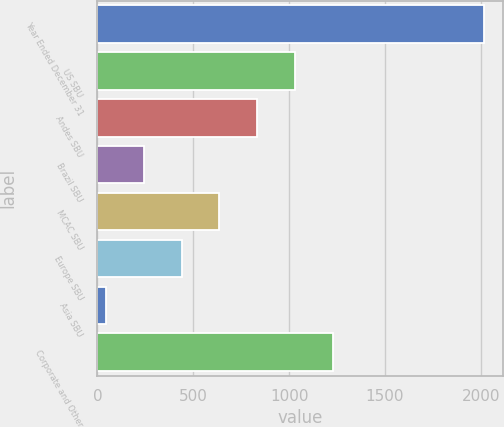Convert chart to OTSL. <chart><loc_0><loc_0><loc_500><loc_500><bar_chart><fcel>Year Ended December 31<fcel>US SBU<fcel>Andes SBU<fcel>Brazil SBU<fcel>MCAC SBU<fcel>Europe SBU<fcel>Asia SBU<fcel>Corporate and Other<nl><fcel>2014<fcel>1030<fcel>833.2<fcel>242.8<fcel>636.4<fcel>439.6<fcel>46<fcel>1226.8<nl></chart> 